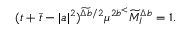<formula> <loc_0><loc_0><loc_500><loc_500>( t + \bar { t } - | a | ^ { 2 } ) ^ { \widetilde { \Delta b } / 2 } \mu ^ { 2 b ^ { < } } \widetilde { M } _ { I } ^ { \Delta b } = 1 .</formula> 